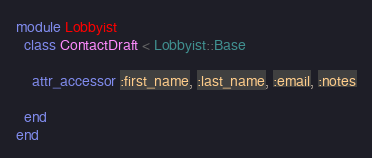Convert code to text. <code><loc_0><loc_0><loc_500><loc_500><_Ruby_>module Lobbyist
  class ContactDraft < Lobbyist::Base
    
    attr_accessor :first_name, :last_name, :email, :notes

  end
end
</code> 